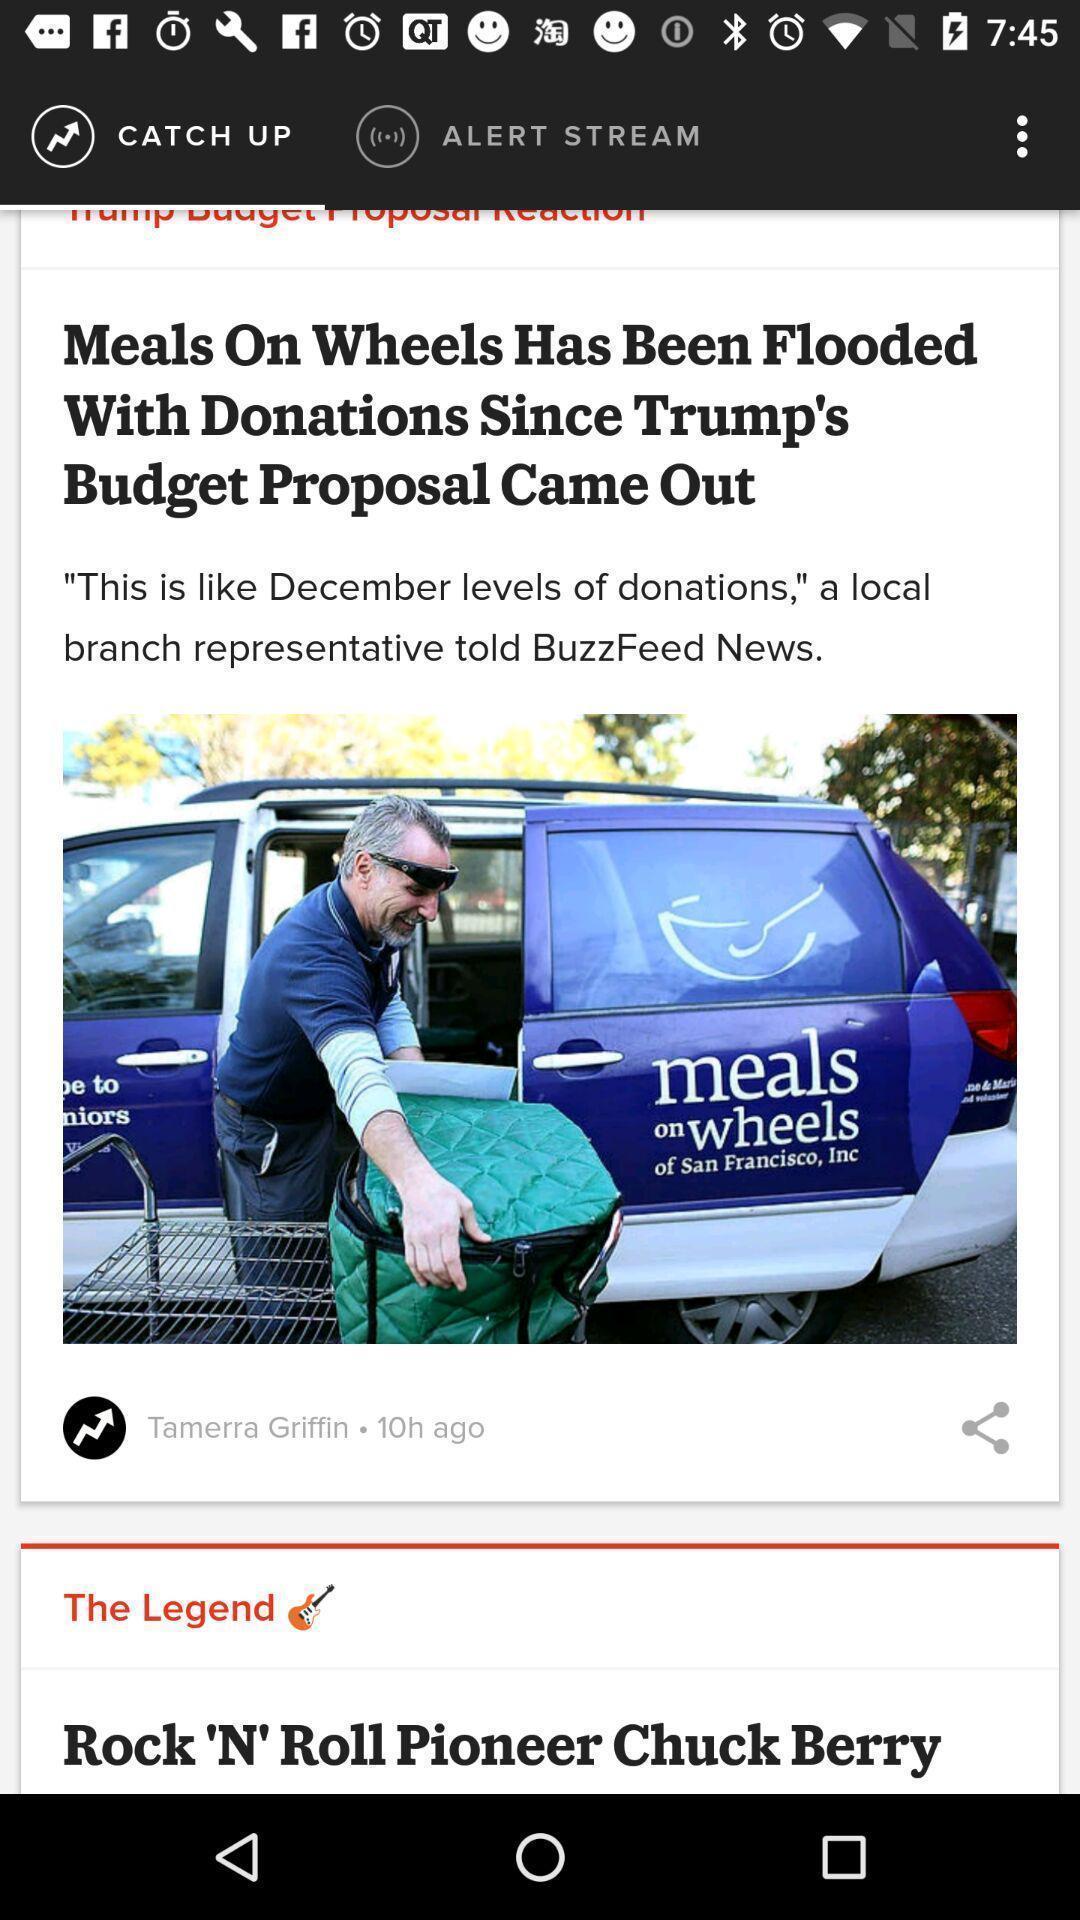Summarize the information in this screenshot. Page showing news article in news app. 